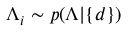Convert formula to latex. <formula><loc_0><loc_0><loc_500><loc_500>\Lambda _ { i } \sim p ( \Lambda | \{ d \} )</formula> 